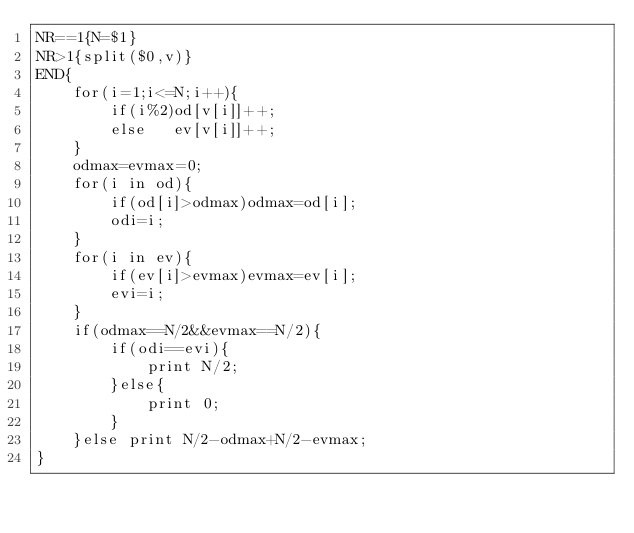<code> <loc_0><loc_0><loc_500><loc_500><_Awk_>NR==1{N=$1}
NR>1{split($0,v)}
END{
	for(i=1;i<=N;i++){
    	if(i%2)od[v[i]]++;
        else   ev[v[i]]++;
    }
    odmax=evmax=0;
    for(i in od){
    	if(od[i]>odmax)odmax=od[i];
        odi=i;
    }
    for(i in ev){
    	if(ev[i]>evmax)evmax=ev[i];
        evi=i;
    }
    if(odmax==N/2&&evmax==N/2){
    	if(odi==evi){
        	print N/2;
        }else{
        	print 0;
        }
    }else print N/2-odmax+N/2-evmax;
}</code> 